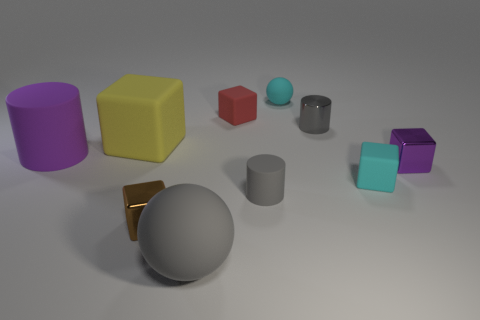What number of objects are both in front of the shiny cylinder and right of the large purple rubber cylinder?
Offer a terse response. 6. What number of objects are tiny objects that are in front of the small red object or things that are behind the large rubber block?
Ensure brevity in your answer.  7. What number of other things are the same size as the yellow rubber block?
Give a very brief answer. 2. The thing in front of the small metallic thing that is left of the gray metallic thing is what shape?
Give a very brief answer. Sphere. Is the color of the cube to the left of the brown thing the same as the cylinder on the left side of the red matte block?
Ensure brevity in your answer.  No. Is there anything else of the same color as the small shiny cylinder?
Offer a terse response. Yes. The small metal cylinder has what color?
Your answer should be compact. Gray. Are any small purple rubber things visible?
Provide a short and direct response. No. There is a gray sphere; are there any tiny cubes left of it?
Provide a succinct answer. Yes. There is a purple thing that is the same shape as the big yellow object; what is its material?
Your response must be concise. Metal. 